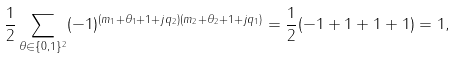Convert formula to latex. <formula><loc_0><loc_0><loc_500><loc_500>\frac { 1 } { 2 } \sum _ { \theta \in \{ 0 , 1 \} ^ { 2 } } ( - 1 ) ^ { ( m _ { 1 } + \theta _ { 1 } + 1 + j q _ { 2 } ) ( m _ { 2 } + \theta _ { 2 } + 1 + j q _ { 1 } ) } = \frac { 1 } { 2 } ( - 1 + 1 + 1 + 1 ) = 1 ,</formula> 